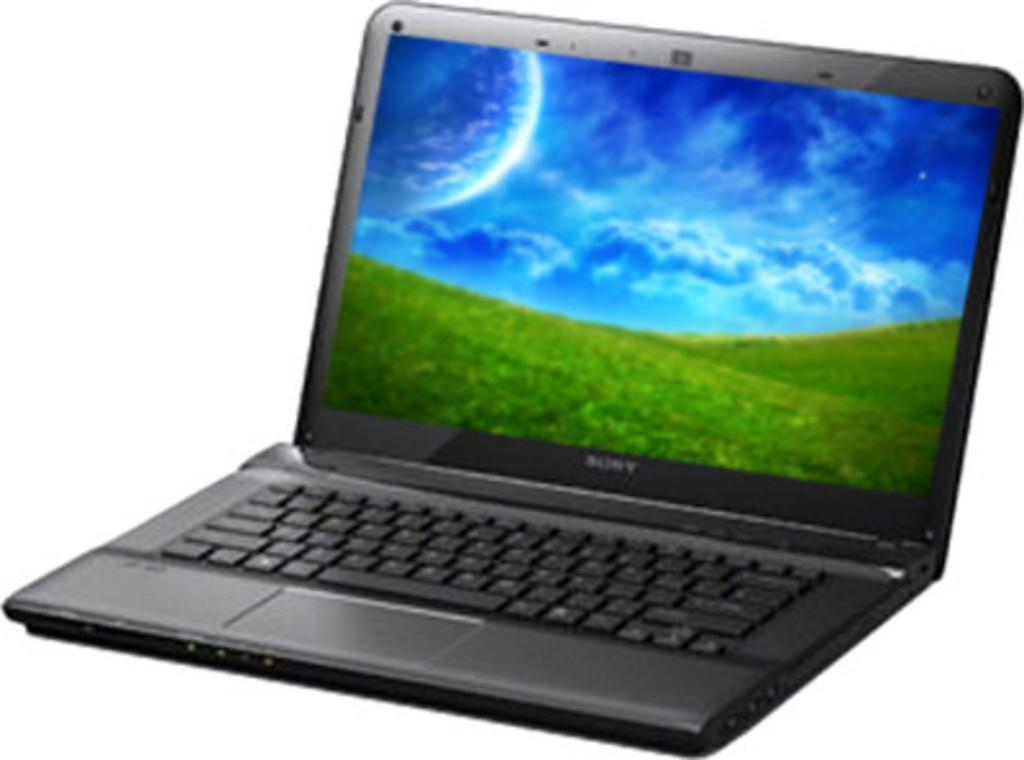<image>
Render a clear and concise summary of the photo. Black Sony laptop which shows a wallpaper of greenery. 